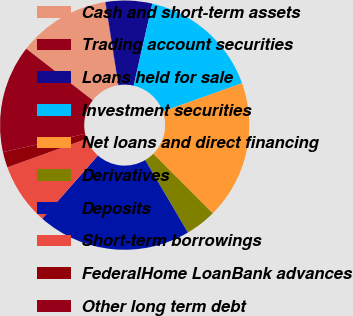<chart> <loc_0><loc_0><loc_500><loc_500><pie_chart><fcel>Cash and short-term assets<fcel>Trading account securities<fcel>Loans held for sale<fcel>Investment securities<fcel>Net loans and direct financing<fcel>Derivatives<fcel>Deposits<fcel>Short-term borrowings<fcel>FederalHome LoanBank advances<fcel>Other long term debt<nl><fcel>11.99%<fcel>0.04%<fcel>6.02%<fcel>15.98%<fcel>17.97%<fcel>4.02%<fcel>19.96%<fcel>8.01%<fcel>2.03%<fcel>13.98%<nl></chart> 